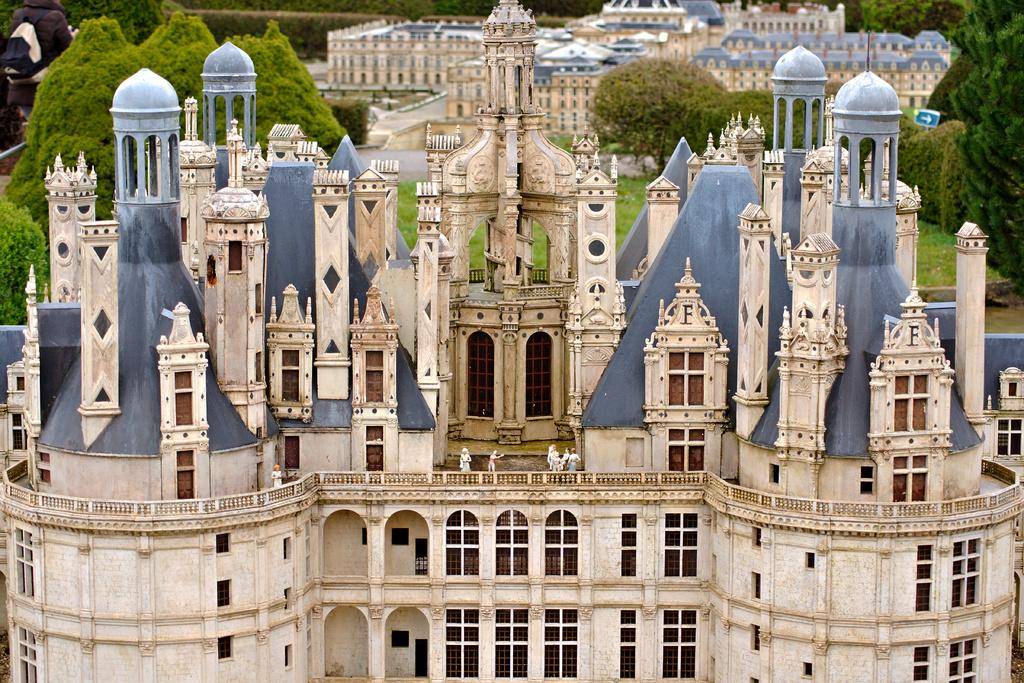What is the main structure in the picture? There is a castle in the picture. What type of vegetation can be seen in the picture? There are trees in the picture. What color is the grass in the picture? The grass in the picture is green. What type of observation can be made about the flag in the picture? There is no flag present in the picture, so no observation can be made about it. 